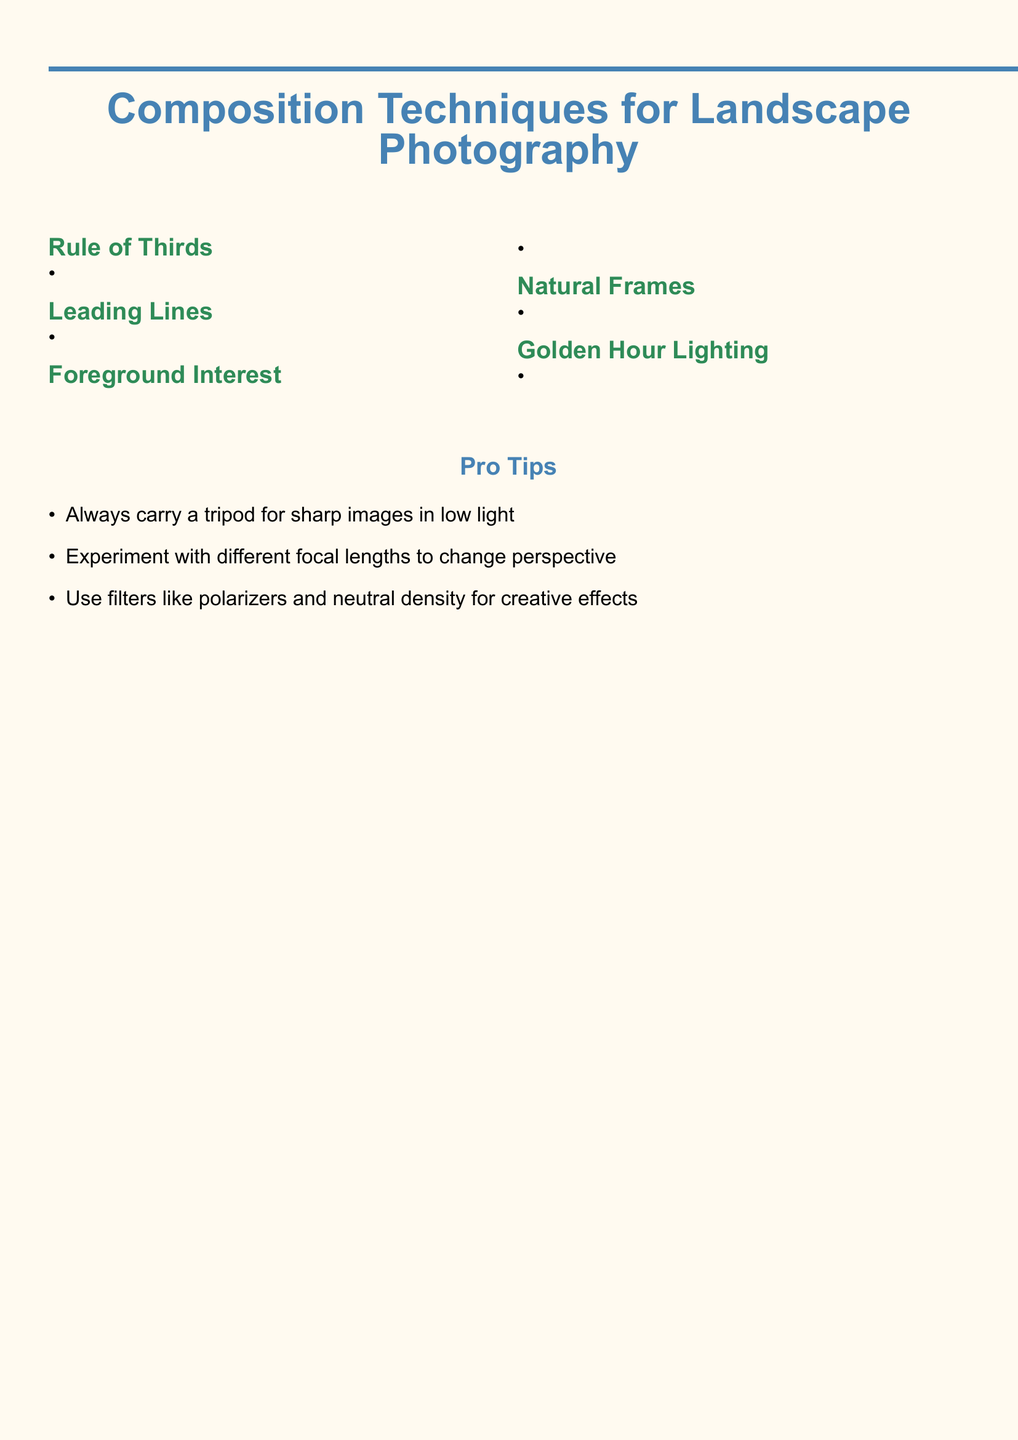What is the first composition technique mentioned? The first technique listed in the document is "Rule of Thirds."
Answer: Rule of Thirds What should you place along the grid lines in the Rule of Thirds? Key elements should be placed along the grid lines or at their intersections.
Answer: Key elements What natural elements can be used as leading lines? The document lists roads, rivers, fences, or mountain ridges as examples of leading lines.
Answer: Roads, rivers, fences, or mountain ridges What effect does shooting during Golden Hour have on the landscape? Shooting during Golden Hour adds soft, warm light that enhances colors and textures.
Answer: Enhances colors and textures What is recommended for sharp images in low light? The document advises to always carry a tripod for sharp images in low light.
Answer: Carry a tripod 